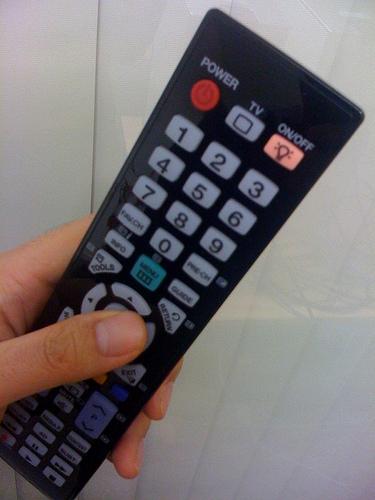How many remotes are in the photo?
Quick response, please. 1. What does the orange button say?
Be succinct. Power. What shape is in the center of the black remote?
Quick response, please. Circle. Which on isn't used to watch TV?
Answer briefly. Remote. What shape is the remote?
Quick response, please. Rectangle. Where is the pause button?
Answer briefly. Under thumb. What is the device used to control?
Short answer required. Tv. Does it have any red buttons?
Answer briefly. Yes. What is in the picture?
Concise answer only. Remote. 